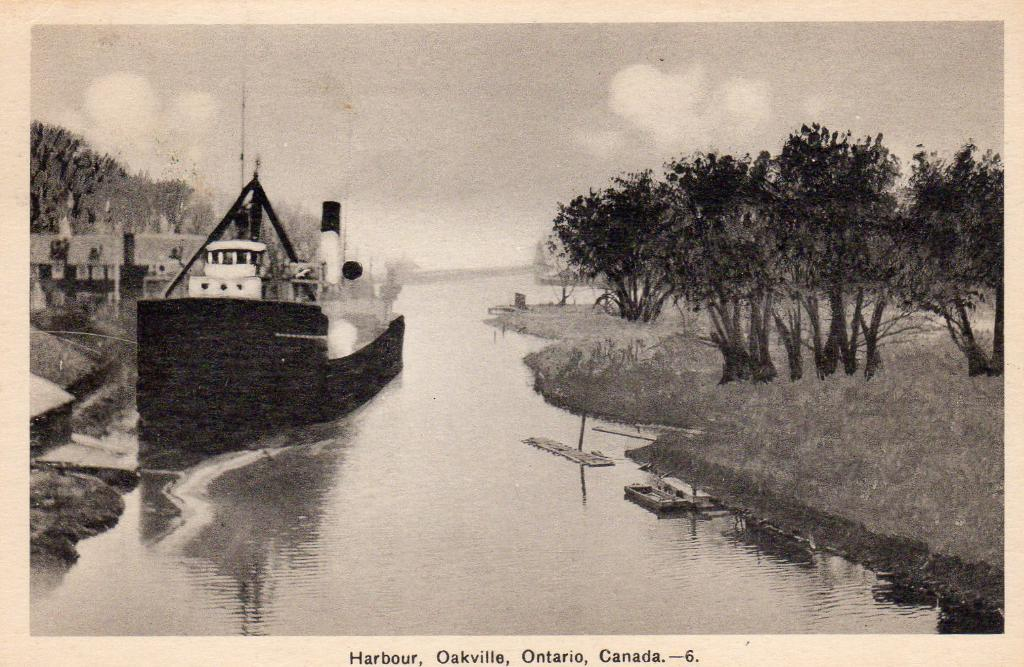<image>
Present a compact description of the photo's key features. An old picture shows a boat in the Harbour in Oakville, Ontario 